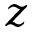Convert formula to latex. <formula><loc_0><loc_0><loc_500><loc_500>z</formula> 